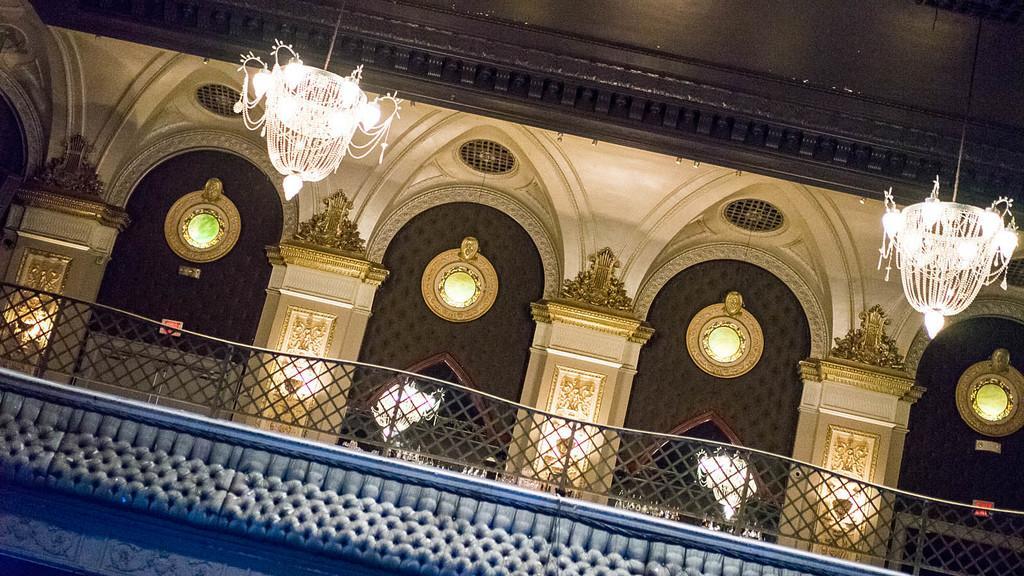Can you describe this image briefly? In this image there is a building in the middle. At the top there are two chandeliers. At the bottom there is a wooden railing. 